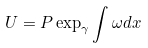<formula> <loc_0><loc_0><loc_500><loc_500>U = P \exp _ { \gamma } \int \omega d x</formula> 